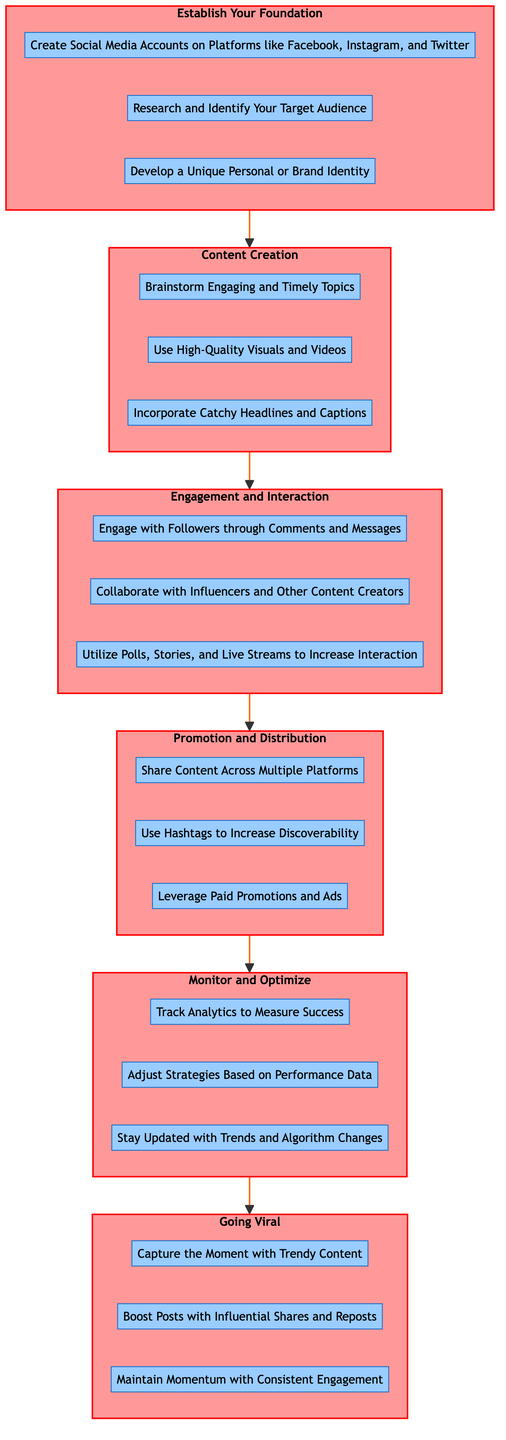What is the last stage in the diagram? The last stage in the diagram is "Going Viral," which is the highest node on the flowchart and signifies the ultimate goal of the process outlined.
Answer: Going Viral How many steps are in the "Engagement and Interaction" stage? The "Engagement and Interaction" stage contains three steps listed under it, highlighting key activities to interact with the audience.
Answer: 3 What is the first step in the "Content Creation" stage? The first step in the "Content Creation" stage is "Brainstorm Engaging and Timely Topics," which comes directly after establishing the foundation.
Answer: Brainstorm Engaging and Timely Topics What is the direct relationship between "Monitor and Optimize" and "Going Viral"? "Monitor and Optimize" is a prerequisite stage that directly leads into "Going Viral," indicating that monitoring and optimization must occur before attempting to go viral.
Answer: Direct connection How many total stages are there in the flowchart? The flowchart includes six distinct stages that represent the journey from establishing the foundation to going viral.
Answer: 6 Which step comes before "Share Content Across Multiple Platforms"? The step that comes before "Share Content Across Multiple Platforms" is "Utilize Polls, Stories, and Live Streams to Increase Interaction," as it is the last step in the previous stage.
Answer: Utilize Polls, Stories, and Live Streams to Increase Interaction What is the pattern of flow in this diagram? The flow is sequential, starting from "Establish Your Foundation" at the bottom, moving upward through various stages until reaching "Going Viral" at the top.
Answer: Sequential flow Which stage includes "Adjust Strategies Based on Performance Data"? "Adjust Strategies Based on Performance Data" is found in the "Monitor and Optimize" stage, which follows the promotion and distribution of content.
Answer: Monitor and Optimize How many steps are listed under "Going Viral"? There are three steps listed under "Going Viral," which detail actions to take to maintain virality once it is achieved.
Answer: 3 